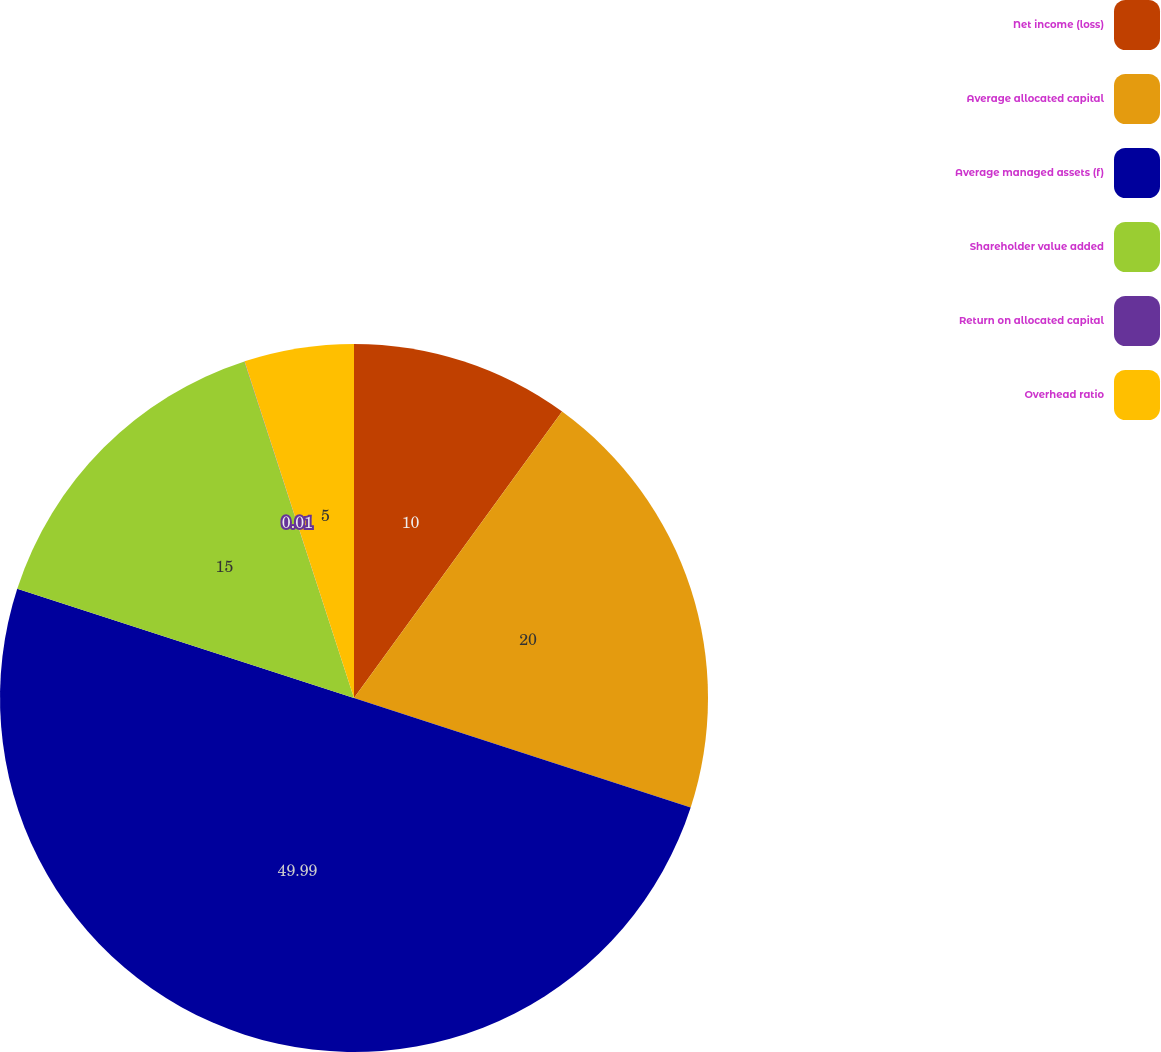Convert chart to OTSL. <chart><loc_0><loc_0><loc_500><loc_500><pie_chart><fcel>Net income (loss)<fcel>Average allocated capital<fcel>Average managed assets (f)<fcel>Shareholder value added<fcel>Return on allocated capital<fcel>Overhead ratio<nl><fcel>10.0%<fcel>20.0%<fcel>49.99%<fcel>15.0%<fcel>0.01%<fcel>5.0%<nl></chart> 